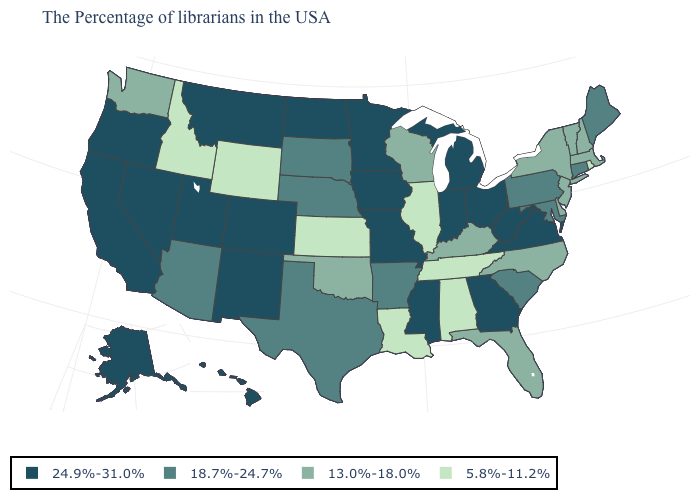What is the value of Delaware?
Concise answer only. 13.0%-18.0%. Name the states that have a value in the range 13.0%-18.0%?
Give a very brief answer. Massachusetts, New Hampshire, Vermont, New York, New Jersey, Delaware, North Carolina, Florida, Kentucky, Wisconsin, Oklahoma, Washington. What is the value of Montana?
Keep it brief. 24.9%-31.0%. What is the value of Oklahoma?
Give a very brief answer. 13.0%-18.0%. Among the states that border Rhode Island , does Connecticut have the highest value?
Keep it brief. Yes. What is the value of New York?
Give a very brief answer. 13.0%-18.0%. What is the value of Delaware?
Short answer required. 13.0%-18.0%. Which states have the highest value in the USA?
Keep it brief. Virginia, West Virginia, Ohio, Georgia, Michigan, Indiana, Mississippi, Missouri, Minnesota, Iowa, North Dakota, Colorado, New Mexico, Utah, Montana, Nevada, California, Oregon, Alaska, Hawaii. Name the states that have a value in the range 24.9%-31.0%?
Give a very brief answer. Virginia, West Virginia, Ohio, Georgia, Michigan, Indiana, Mississippi, Missouri, Minnesota, Iowa, North Dakota, Colorado, New Mexico, Utah, Montana, Nevada, California, Oregon, Alaska, Hawaii. What is the value of Arizona?
Give a very brief answer. 18.7%-24.7%. Name the states that have a value in the range 13.0%-18.0%?
Short answer required. Massachusetts, New Hampshire, Vermont, New York, New Jersey, Delaware, North Carolina, Florida, Kentucky, Wisconsin, Oklahoma, Washington. Name the states that have a value in the range 18.7%-24.7%?
Be succinct. Maine, Connecticut, Maryland, Pennsylvania, South Carolina, Arkansas, Nebraska, Texas, South Dakota, Arizona. Among the states that border South Carolina , which have the lowest value?
Write a very short answer. North Carolina. What is the value of New Mexico?
Be succinct. 24.9%-31.0%. 